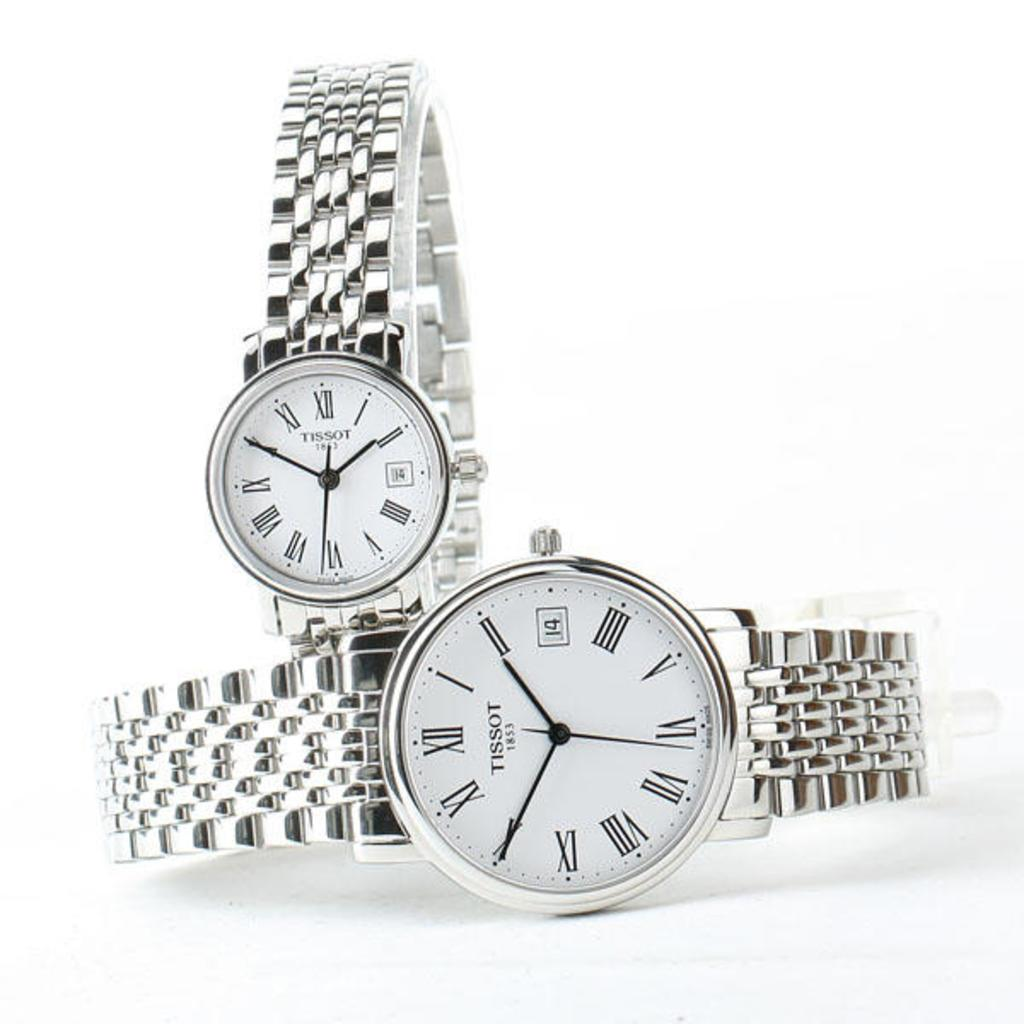<image>
Write a terse but informative summary of the picture. 2 watches that are made by Tissot and have a clear color with the date 14 on them. 